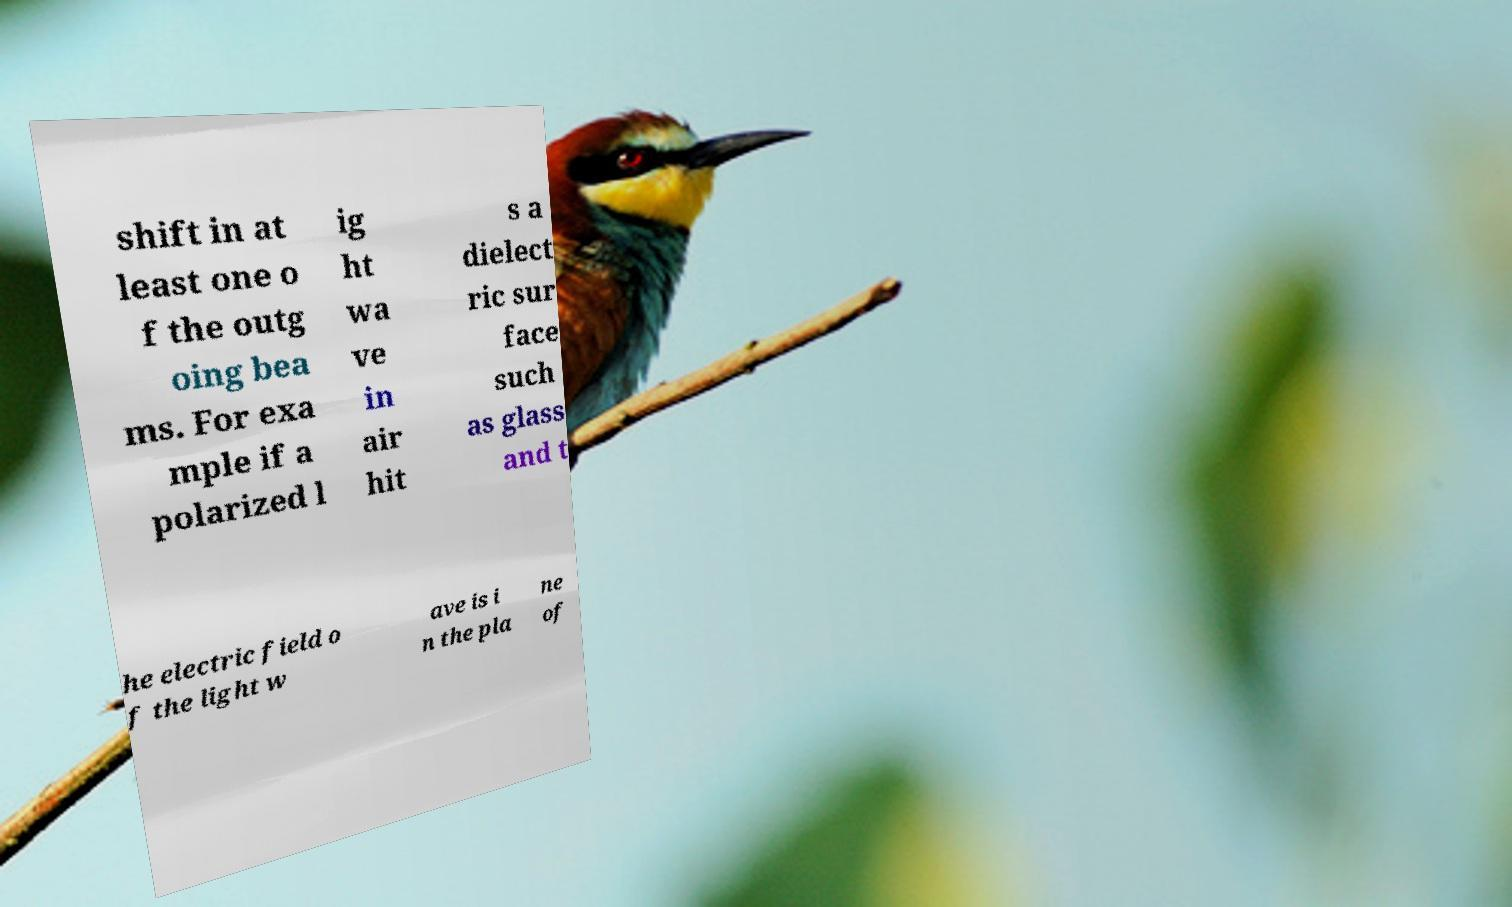There's text embedded in this image that I need extracted. Can you transcribe it verbatim? shift in at least one o f the outg oing bea ms. For exa mple if a polarized l ig ht wa ve in air hit s a dielect ric sur face such as glass and t he electric field o f the light w ave is i n the pla ne of 